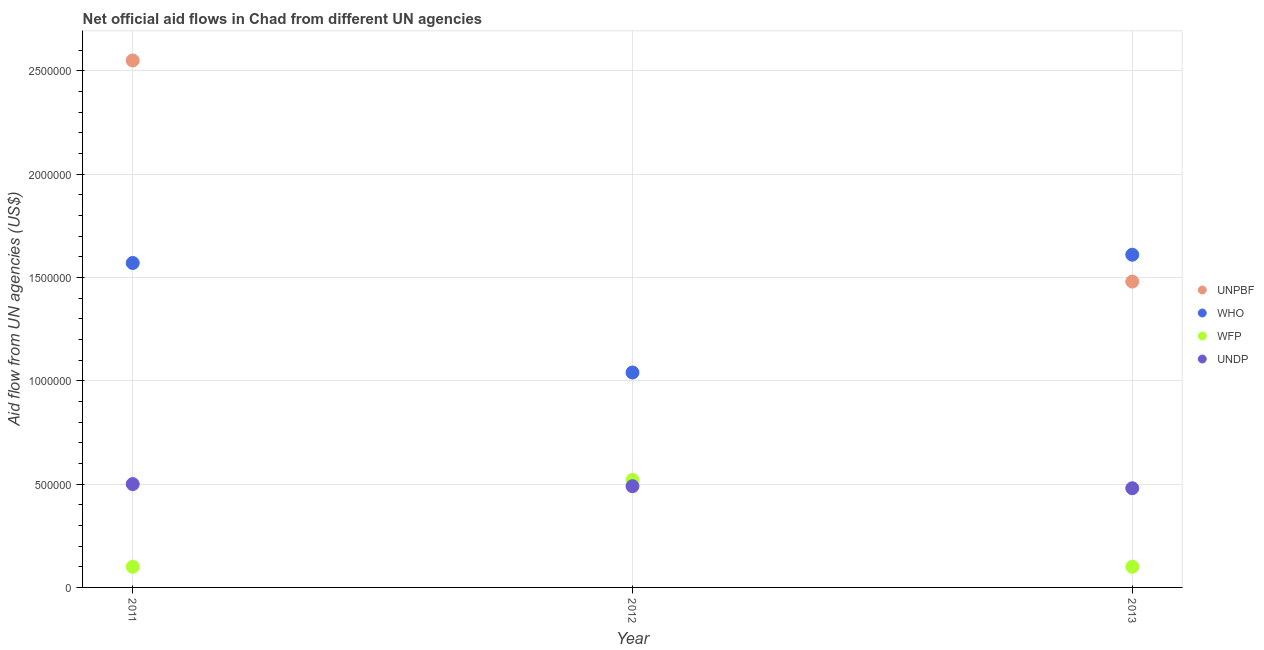How many different coloured dotlines are there?
Your answer should be compact. 4. Is the number of dotlines equal to the number of legend labels?
Offer a terse response. No. What is the amount of aid given by wfp in 2011?
Keep it short and to the point. 1.00e+05. Across all years, what is the maximum amount of aid given by unpbf?
Provide a short and direct response. 2.55e+06. Across all years, what is the minimum amount of aid given by who?
Give a very brief answer. 1.04e+06. What is the total amount of aid given by wfp in the graph?
Provide a short and direct response. 7.20e+05. What is the difference between the amount of aid given by who in 2011 and that in 2012?
Give a very brief answer. 5.30e+05. What is the difference between the amount of aid given by wfp in 2011 and the amount of aid given by who in 2013?
Offer a very short reply. -1.51e+06. What is the average amount of aid given by who per year?
Offer a terse response. 1.41e+06. In the year 2011, what is the difference between the amount of aid given by undp and amount of aid given by who?
Your answer should be very brief. -1.07e+06. What is the ratio of the amount of aid given by wfp in 2011 to that in 2012?
Ensure brevity in your answer.  0.19. Is the amount of aid given by wfp in 2011 less than that in 2012?
Give a very brief answer. Yes. Is the difference between the amount of aid given by unpbf in 2011 and 2013 greater than the difference between the amount of aid given by wfp in 2011 and 2013?
Your answer should be very brief. Yes. What is the difference between the highest and the lowest amount of aid given by wfp?
Your answer should be compact. 4.20e+05. In how many years, is the amount of aid given by unpbf greater than the average amount of aid given by unpbf taken over all years?
Your response must be concise. 2. Is it the case that in every year, the sum of the amount of aid given by unpbf and amount of aid given by undp is greater than the sum of amount of aid given by wfp and amount of aid given by who?
Give a very brief answer. Yes. Is it the case that in every year, the sum of the amount of aid given by unpbf and amount of aid given by who is greater than the amount of aid given by wfp?
Keep it short and to the point. Yes. Are the values on the major ticks of Y-axis written in scientific E-notation?
Ensure brevity in your answer.  No. Does the graph contain any zero values?
Provide a succinct answer. Yes. Does the graph contain grids?
Provide a succinct answer. Yes. Where does the legend appear in the graph?
Provide a succinct answer. Center right. How many legend labels are there?
Your answer should be very brief. 4. How are the legend labels stacked?
Offer a terse response. Vertical. What is the title of the graph?
Make the answer very short. Net official aid flows in Chad from different UN agencies. What is the label or title of the Y-axis?
Offer a very short reply. Aid flow from UN agencies (US$). What is the Aid flow from UN agencies (US$) of UNPBF in 2011?
Offer a very short reply. 2.55e+06. What is the Aid flow from UN agencies (US$) in WHO in 2011?
Offer a very short reply. 1.57e+06. What is the Aid flow from UN agencies (US$) in WFP in 2011?
Your answer should be compact. 1.00e+05. What is the Aid flow from UN agencies (US$) of WHO in 2012?
Give a very brief answer. 1.04e+06. What is the Aid flow from UN agencies (US$) of WFP in 2012?
Offer a very short reply. 5.20e+05. What is the Aid flow from UN agencies (US$) of UNPBF in 2013?
Provide a succinct answer. 1.48e+06. What is the Aid flow from UN agencies (US$) in WHO in 2013?
Your response must be concise. 1.61e+06. What is the Aid flow from UN agencies (US$) of WFP in 2013?
Provide a succinct answer. 1.00e+05. Across all years, what is the maximum Aid flow from UN agencies (US$) of UNPBF?
Your answer should be compact. 2.55e+06. Across all years, what is the maximum Aid flow from UN agencies (US$) of WHO?
Your response must be concise. 1.61e+06. Across all years, what is the maximum Aid flow from UN agencies (US$) of WFP?
Your response must be concise. 5.20e+05. Across all years, what is the minimum Aid flow from UN agencies (US$) of UNPBF?
Give a very brief answer. 0. Across all years, what is the minimum Aid flow from UN agencies (US$) of WHO?
Your answer should be very brief. 1.04e+06. Across all years, what is the minimum Aid flow from UN agencies (US$) of UNDP?
Your answer should be compact. 4.80e+05. What is the total Aid flow from UN agencies (US$) of UNPBF in the graph?
Ensure brevity in your answer.  4.03e+06. What is the total Aid flow from UN agencies (US$) of WHO in the graph?
Make the answer very short. 4.22e+06. What is the total Aid flow from UN agencies (US$) in WFP in the graph?
Give a very brief answer. 7.20e+05. What is the total Aid flow from UN agencies (US$) in UNDP in the graph?
Offer a very short reply. 1.47e+06. What is the difference between the Aid flow from UN agencies (US$) of WHO in 2011 and that in 2012?
Provide a short and direct response. 5.30e+05. What is the difference between the Aid flow from UN agencies (US$) in WFP in 2011 and that in 2012?
Offer a terse response. -4.20e+05. What is the difference between the Aid flow from UN agencies (US$) in UNDP in 2011 and that in 2012?
Give a very brief answer. 10000. What is the difference between the Aid flow from UN agencies (US$) in UNPBF in 2011 and that in 2013?
Give a very brief answer. 1.07e+06. What is the difference between the Aid flow from UN agencies (US$) in WHO in 2011 and that in 2013?
Offer a terse response. -4.00e+04. What is the difference between the Aid flow from UN agencies (US$) of WFP in 2011 and that in 2013?
Keep it short and to the point. 0. What is the difference between the Aid flow from UN agencies (US$) in UNDP in 2011 and that in 2013?
Offer a very short reply. 2.00e+04. What is the difference between the Aid flow from UN agencies (US$) of WHO in 2012 and that in 2013?
Offer a very short reply. -5.70e+05. What is the difference between the Aid flow from UN agencies (US$) of WFP in 2012 and that in 2013?
Your answer should be compact. 4.20e+05. What is the difference between the Aid flow from UN agencies (US$) in UNPBF in 2011 and the Aid flow from UN agencies (US$) in WHO in 2012?
Provide a short and direct response. 1.51e+06. What is the difference between the Aid flow from UN agencies (US$) in UNPBF in 2011 and the Aid flow from UN agencies (US$) in WFP in 2012?
Offer a terse response. 2.03e+06. What is the difference between the Aid flow from UN agencies (US$) in UNPBF in 2011 and the Aid flow from UN agencies (US$) in UNDP in 2012?
Offer a very short reply. 2.06e+06. What is the difference between the Aid flow from UN agencies (US$) in WHO in 2011 and the Aid flow from UN agencies (US$) in WFP in 2012?
Your response must be concise. 1.05e+06. What is the difference between the Aid flow from UN agencies (US$) of WHO in 2011 and the Aid flow from UN agencies (US$) of UNDP in 2012?
Keep it short and to the point. 1.08e+06. What is the difference between the Aid flow from UN agencies (US$) of WFP in 2011 and the Aid flow from UN agencies (US$) of UNDP in 2012?
Ensure brevity in your answer.  -3.90e+05. What is the difference between the Aid flow from UN agencies (US$) of UNPBF in 2011 and the Aid flow from UN agencies (US$) of WHO in 2013?
Provide a succinct answer. 9.40e+05. What is the difference between the Aid flow from UN agencies (US$) of UNPBF in 2011 and the Aid flow from UN agencies (US$) of WFP in 2013?
Give a very brief answer. 2.45e+06. What is the difference between the Aid flow from UN agencies (US$) in UNPBF in 2011 and the Aid flow from UN agencies (US$) in UNDP in 2013?
Make the answer very short. 2.07e+06. What is the difference between the Aid flow from UN agencies (US$) in WHO in 2011 and the Aid flow from UN agencies (US$) in WFP in 2013?
Your response must be concise. 1.47e+06. What is the difference between the Aid flow from UN agencies (US$) in WHO in 2011 and the Aid flow from UN agencies (US$) in UNDP in 2013?
Provide a short and direct response. 1.09e+06. What is the difference between the Aid flow from UN agencies (US$) in WFP in 2011 and the Aid flow from UN agencies (US$) in UNDP in 2013?
Offer a terse response. -3.80e+05. What is the difference between the Aid flow from UN agencies (US$) in WHO in 2012 and the Aid flow from UN agencies (US$) in WFP in 2013?
Your response must be concise. 9.40e+05. What is the difference between the Aid flow from UN agencies (US$) of WHO in 2012 and the Aid flow from UN agencies (US$) of UNDP in 2013?
Your answer should be compact. 5.60e+05. What is the difference between the Aid flow from UN agencies (US$) in WFP in 2012 and the Aid flow from UN agencies (US$) in UNDP in 2013?
Ensure brevity in your answer.  4.00e+04. What is the average Aid flow from UN agencies (US$) in UNPBF per year?
Your response must be concise. 1.34e+06. What is the average Aid flow from UN agencies (US$) in WHO per year?
Your response must be concise. 1.41e+06. What is the average Aid flow from UN agencies (US$) of WFP per year?
Offer a terse response. 2.40e+05. In the year 2011, what is the difference between the Aid flow from UN agencies (US$) of UNPBF and Aid flow from UN agencies (US$) of WHO?
Provide a succinct answer. 9.80e+05. In the year 2011, what is the difference between the Aid flow from UN agencies (US$) of UNPBF and Aid flow from UN agencies (US$) of WFP?
Ensure brevity in your answer.  2.45e+06. In the year 2011, what is the difference between the Aid flow from UN agencies (US$) in UNPBF and Aid flow from UN agencies (US$) in UNDP?
Offer a terse response. 2.05e+06. In the year 2011, what is the difference between the Aid flow from UN agencies (US$) of WHO and Aid flow from UN agencies (US$) of WFP?
Your answer should be compact. 1.47e+06. In the year 2011, what is the difference between the Aid flow from UN agencies (US$) in WHO and Aid flow from UN agencies (US$) in UNDP?
Your answer should be very brief. 1.07e+06. In the year 2011, what is the difference between the Aid flow from UN agencies (US$) in WFP and Aid flow from UN agencies (US$) in UNDP?
Your answer should be compact. -4.00e+05. In the year 2012, what is the difference between the Aid flow from UN agencies (US$) of WHO and Aid flow from UN agencies (US$) of WFP?
Ensure brevity in your answer.  5.20e+05. In the year 2012, what is the difference between the Aid flow from UN agencies (US$) of WHO and Aid flow from UN agencies (US$) of UNDP?
Provide a short and direct response. 5.50e+05. In the year 2013, what is the difference between the Aid flow from UN agencies (US$) of UNPBF and Aid flow from UN agencies (US$) of WHO?
Your answer should be compact. -1.30e+05. In the year 2013, what is the difference between the Aid flow from UN agencies (US$) in UNPBF and Aid flow from UN agencies (US$) in WFP?
Give a very brief answer. 1.38e+06. In the year 2013, what is the difference between the Aid flow from UN agencies (US$) in UNPBF and Aid flow from UN agencies (US$) in UNDP?
Your response must be concise. 1.00e+06. In the year 2013, what is the difference between the Aid flow from UN agencies (US$) of WHO and Aid flow from UN agencies (US$) of WFP?
Provide a succinct answer. 1.51e+06. In the year 2013, what is the difference between the Aid flow from UN agencies (US$) of WHO and Aid flow from UN agencies (US$) of UNDP?
Keep it short and to the point. 1.13e+06. In the year 2013, what is the difference between the Aid flow from UN agencies (US$) in WFP and Aid flow from UN agencies (US$) in UNDP?
Your answer should be compact. -3.80e+05. What is the ratio of the Aid flow from UN agencies (US$) of WHO in 2011 to that in 2012?
Offer a terse response. 1.51. What is the ratio of the Aid flow from UN agencies (US$) of WFP in 2011 to that in 2012?
Your answer should be very brief. 0.19. What is the ratio of the Aid flow from UN agencies (US$) in UNDP in 2011 to that in 2012?
Your answer should be very brief. 1.02. What is the ratio of the Aid flow from UN agencies (US$) of UNPBF in 2011 to that in 2013?
Your answer should be very brief. 1.72. What is the ratio of the Aid flow from UN agencies (US$) of WHO in 2011 to that in 2013?
Give a very brief answer. 0.98. What is the ratio of the Aid flow from UN agencies (US$) in WFP in 2011 to that in 2013?
Give a very brief answer. 1. What is the ratio of the Aid flow from UN agencies (US$) of UNDP in 2011 to that in 2013?
Give a very brief answer. 1.04. What is the ratio of the Aid flow from UN agencies (US$) in WHO in 2012 to that in 2013?
Your answer should be very brief. 0.65. What is the ratio of the Aid flow from UN agencies (US$) in UNDP in 2012 to that in 2013?
Provide a succinct answer. 1.02. What is the difference between the highest and the second highest Aid flow from UN agencies (US$) in WFP?
Give a very brief answer. 4.20e+05. What is the difference between the highest and the lowest Aid flow from UN agencies (US$) in UNPBF?
Provide a short and direct response. 2.55e+06. What is the difference between the highest and the lowest Aid flow from UN agencies (US$) of WHO?
Give a very brief answer. 5.70e+05. What is the difference between the highest and the lowest Aid flow from UN agencies (US$) of WFP?
Provide a short and direct response. 4.20e+05. What is the difference between the highest and the lowest Aid flow from UN agencies (US$) in UNDP?
Your answer should be very brief. 2.00e+04. 